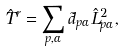<formula> <loc_0><loc_0><loc_500><loc_500>\hat { T } ^ { r } = \sum _ { p , \alpha } \tilde { d } _ { p \alpha } \hat { L } _ { p \alpha } ^ { 2 } ,</formula> 